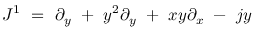<formula> <loc_0><loc_0><loc_500><loc_500>J ^ { 1 } \ = \ \partial _ { y } \ + \ y ^ { 2 } \partial _ { y } \ + \ x y \partial _ { x } \ - \ j y</formula> 